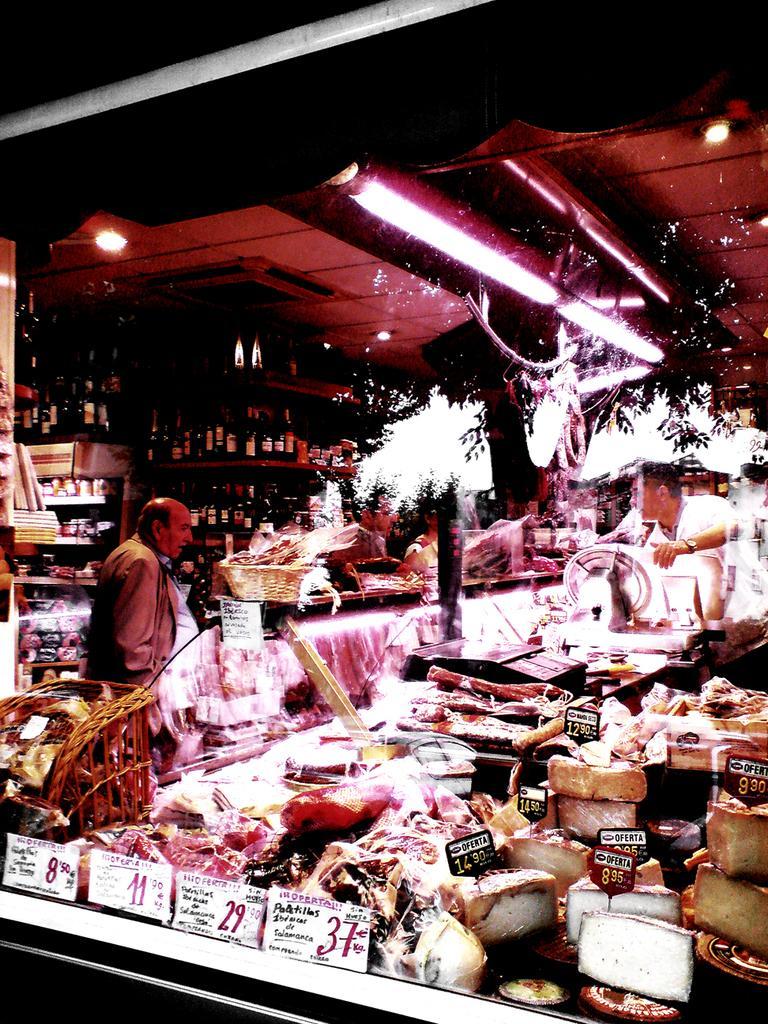In one or two sentences, can you explain what this image depicts? This picture might be taken in a store in this picture, on the right side there are some food items and tables and one person is standing. And on the left side there is another person who is standing and also there are some tables, on the tables there are some baskets and some other items. In the background there are some cupboards, in that cupboards there are some bottles. On the top there is ceiling and some lights. 